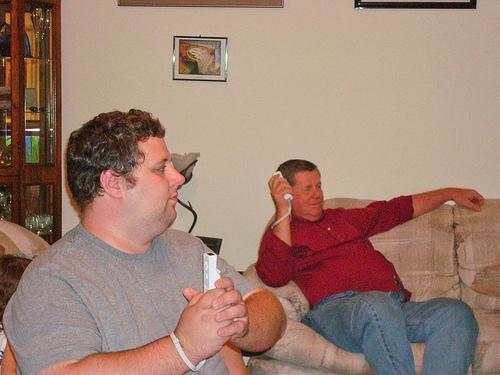Question: what are the men doing?
Choices:
A. Playing basketall.
B. Playing football.
C. Playing soccer.
D. Playing a game.
Answer with the letter. Answer: D Question: what color are the controllers?
Choices:
A. Black.
B. White.
C. Blue.
D. Yellow.
Answer with the letter. Answer: B Question: where are the controllers?
Choices:
A. The women's hands.
B. The pilot's hands.
C. The police officer's hands.
D. The men's hands.
Answer with the letter. Answer: D Question: who is playing the game?
Choices:
A. The women.
B. The children.
C. The men.
D. The students.
Answer with the letter. Answer: C 